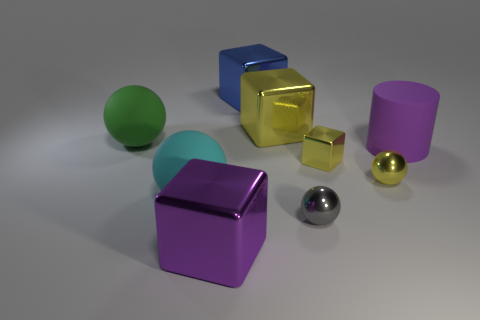How many blue metal things are there?
Make the answer very short. 1. What number of matte things are big objects or large blue blocks?
Offer a very short reply. 3. What number of other blocks are the same color as the small metal cube?
Keep it short and to the point. 1. There is a yellow block behind the green matte ball that is on the left side of the gray metallic ball; what is it made of?
Your answer should be compact. Metal. What is the size of the gray metal object?
Your response must be concise. Small. What number of yellow metal blocks have the same size as the gray object?
Provide a short and direct response. 1. What number of yellow objects are the same shape as the cyan thing?
Keep it short and to the point. 1. Is the number of small metallic spheres that are on the right side of the tiny gray thing the same as the number of tiny blue spheres?
Your response must be concise. No. Is there anything else that is the same size as the gray shiny thing?
Give a very brief answer. Yes. There is a green matte thing that is the same size as the blue block; what is its shape?
Offer a very short reply. Sphere. 